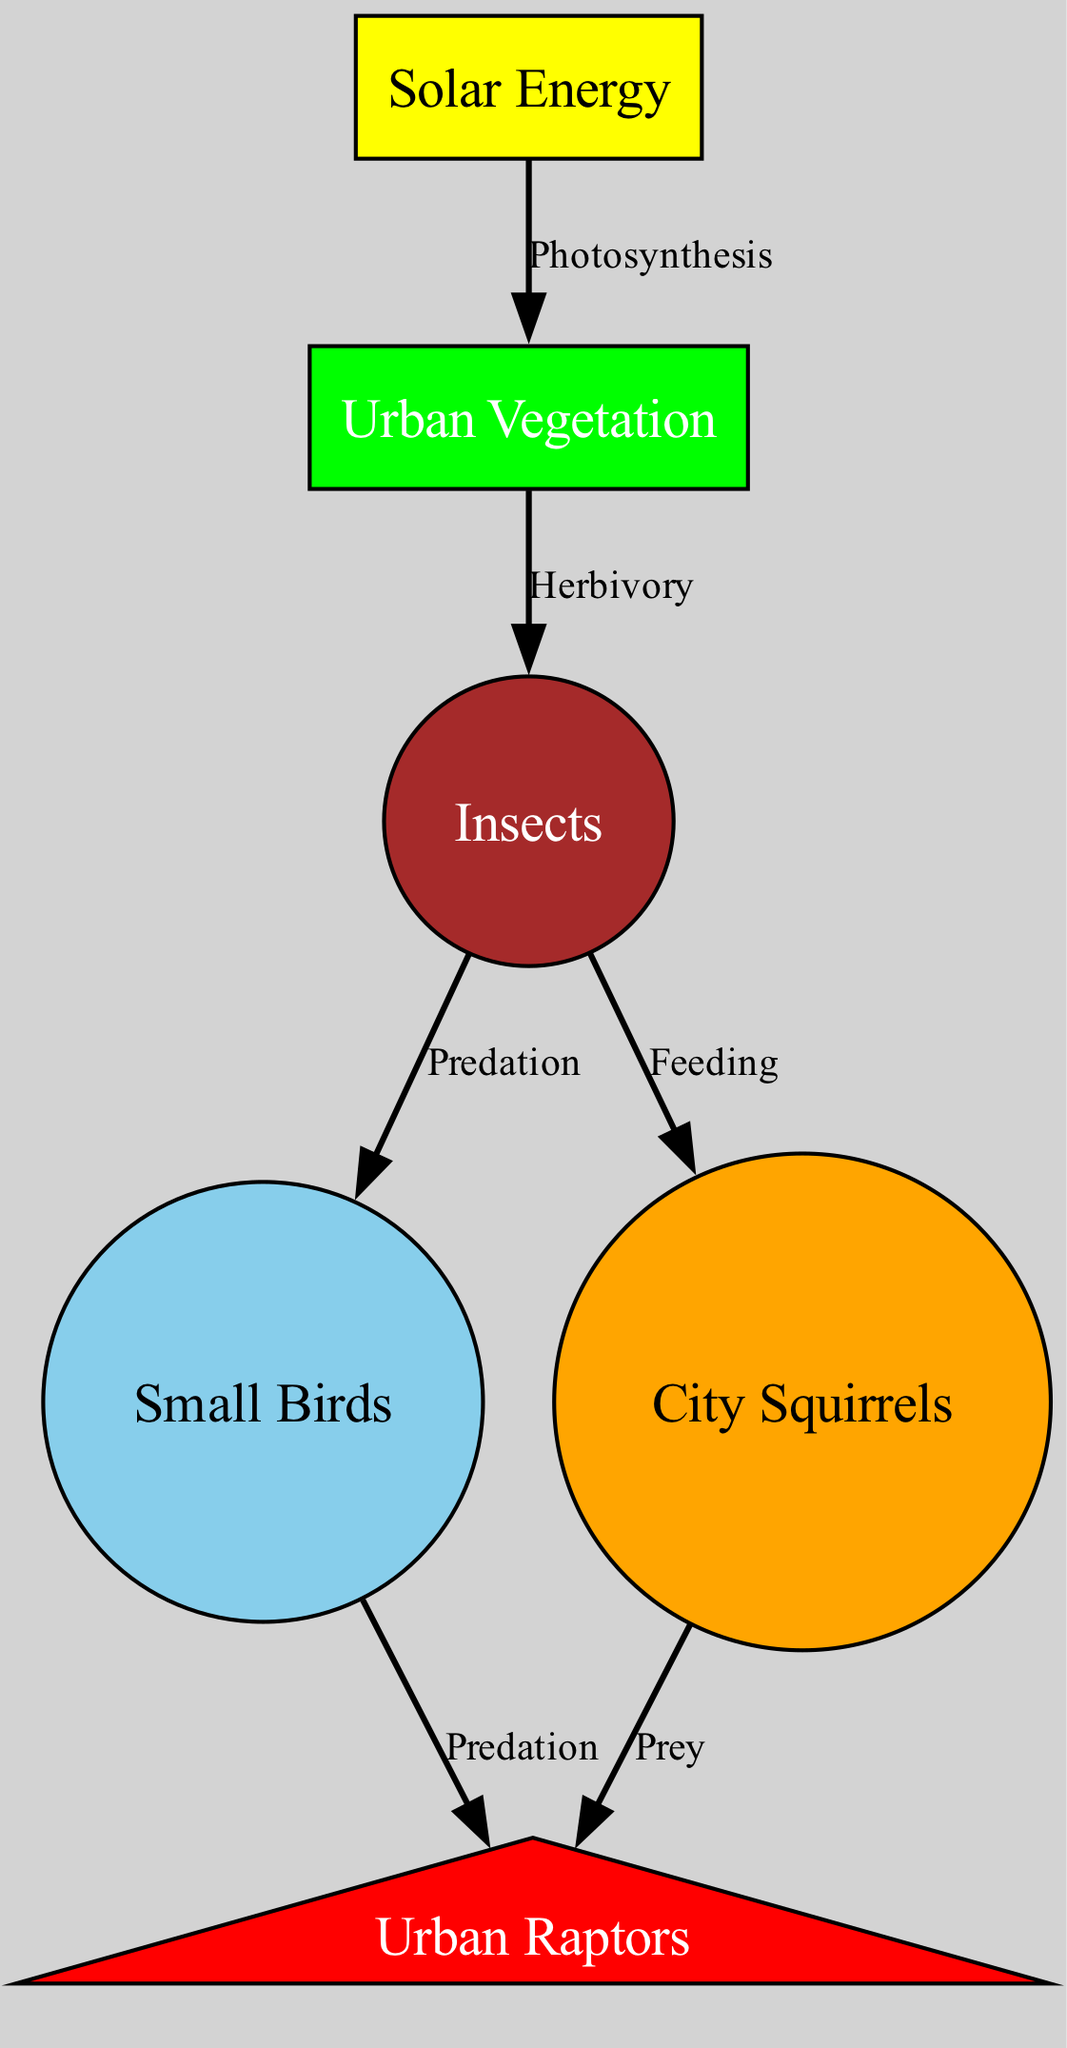What is the initial source of energy in the food chain? The food chain starts with "Solar Energy," which is the primary source of energy for all living organisms in the ecosystem.
Answer: Solar Energy How many nodes are in the diagram? The diagram consists of 6 nodes, representing the different components of the urban ecosystem.
Answer: 6 What type of organism directly consumes Urban Vegetation? Insects directly consume Urban Vegetation through herbivory, as indicated by the relationship in the diagram.
Answer: Insects Which organism is at the top of the food chain? Urban Raptors are positioned at the top of the food chain as they prey on both small birds and city squirrels.
Answer: Urban Raptors What relationship does Urban Vegetation have with Solar Energy? Urban Vegetation captures Solar Energy through the process of photosynthesis, indicating a direct dependency on sunlight for energy conversion.
Answer: Photosynthesis Which two organisms are preyed upon by Urban Raptors? Urban Raptors prey upon small birds and city squirrels, showcasing their role as top predators in the ecosystem.
Answer: Small Birds, City Squirrels How many edges are represented in the diagram? The diagram contains 6 edges, illustrating the various feeding relationships and energy flow between the different organisms.
Answer: 6 What is the relationship between Insects and Small Birds? The relationship between Insects and Small Birds is one of predation, where small birds feed on insects.
Answer: Predation Which organism relies on both Insects and Urban Vegetation for sustenance? City Squirrels feed on Insects, which are herbivores feeding on Urban Vegetation, thus they depend on both for their diet.
Answer: City Squirrels 